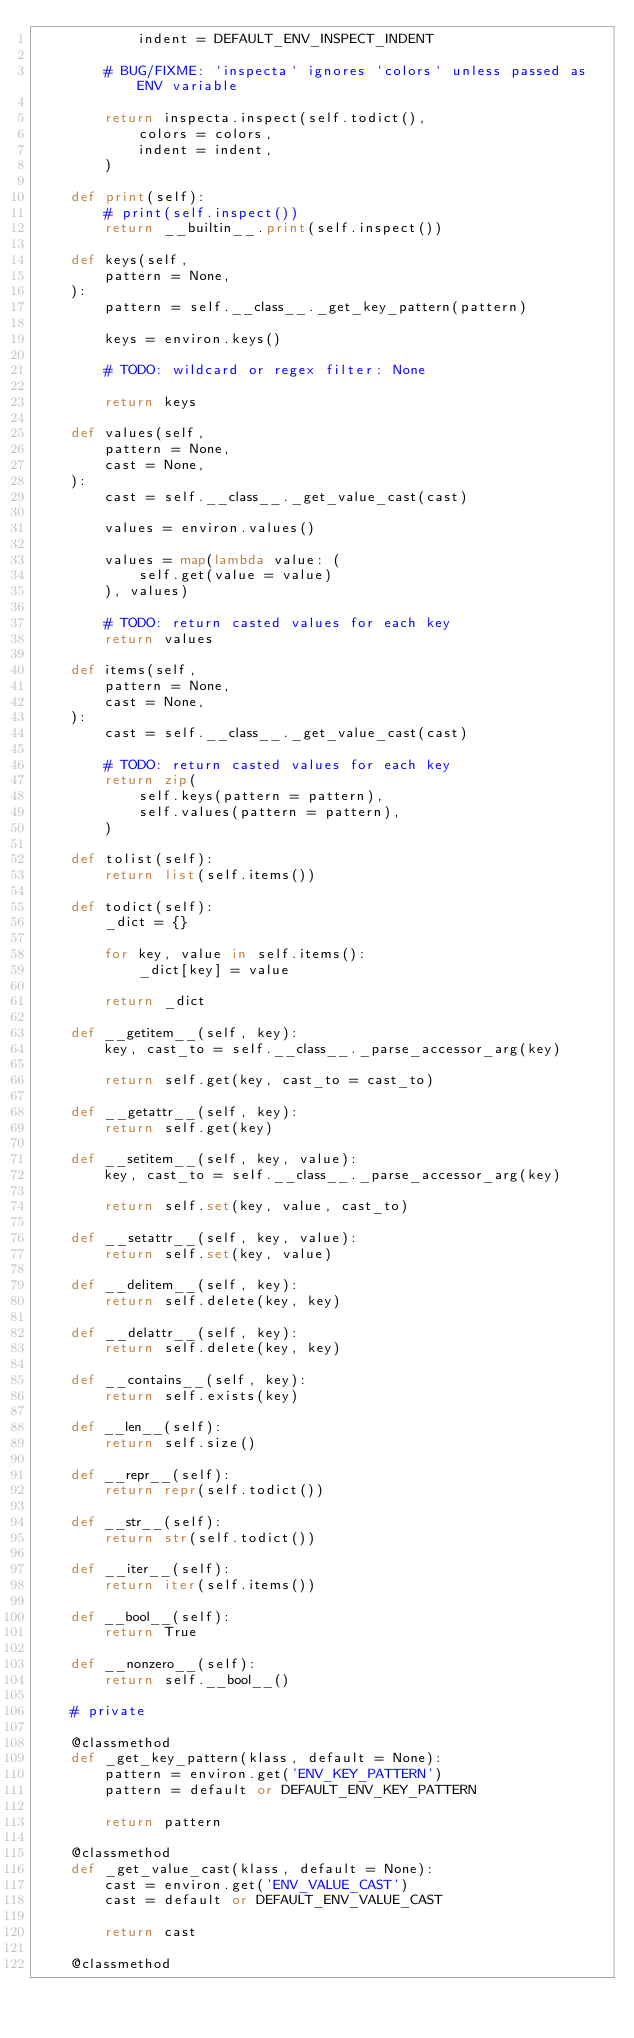Convert code to text. <code><loc_0><loc_0><loc_500><loc_500><_Python_>            indent = DEFAULT_ENV_INSPECT_INDENT

        # BUG/FIXME: `inspecta` ignores `colors` unless passed as ENV variable

        return inspecta.inspect(self.todict(),
            colors = colors,
            indent = indent,
        )

    def print(self):
        # print(self.inspect())
        return __builtin__.print(self.inspect())

    def keys(self,
        pattern = None,
    ):
        pattern = self.__class__._get_key_pattern(pattern)

        keys = environ.keys()

        # TODO: wildcard or regex filter: None

        return keys

    def values(self,
        pattern = None,
        cast = None,
    ):
        cast = self.__class__._get_value_cast(cast)

        values = environ.values()

        values = map(lambda value: (
            self.get(value = value)
        ), values)

        # TODO: return casted values for each key
        return values

    def items(self,
        pattern = None,
        cast = None,
    ):
        cast = self.__class__._get_value_cast(cast)

        # TODO: return casted values for each key
        return zip(
            self.keys(pattern = pattern),
            self.values(pattern = pattern),
        )

    def tolist(self):
        return list(self.items())

    def todict(self):
        _dict = {}

        for key, value in self.items():
            _dict[key] = value

        return _dict

    def __getitem__(self, key):
        key, cast_to = self.__class__._parse_accessor_arg(key)

        return self.get(key, cast_to = cast_to)

    def __getattr__(self, key):
        return self.get(key)

    def __setitem__(self, key, value):
        key, cast_to = self.__class__._parse_accessor_arg(key)

        return self.set(key, value, cast_to)

    def __setattr__(self, key, value):
        return self.set(key, value)

    def __delitem__(self, key):
        return self.delete(key, key)

    def __delattr__(self, key):
        return self.delete(key, key)

    def __contains__(self, key):
        return self.exists(key)

    def __len__(self):
        return self.size()

    def __repr__(self):
        return repr(self.todict())

    def __str__(self):
        return str(self.todict())

    def __iter__(self):
        return iter(self.items())

    def __bool__(self):
        return True

    def __nonzero__(self):
        return self.__bool__()

    # private

    @classmethod
    def _get_key_pattern(klass, default = None):
        pattern = environ.get('ENV_KEY_PATTERN')
        pattern = default or DEFAULT_ENV_KEY_PATTERN

        return pattern

    @classmethod
    def _get_value_cast(klass, default = None):
        cast = environ.get('ENV_VALUE_CAST')
        cast = default or DEFAULT_ENV_VALUE_CAST

        return cast

    @classmethod</code> 